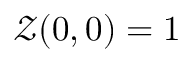<formula> <loc_0><loc_0><loc_500><loc_500>\mathcal { Z } ( 0 , 0 ) = 1</formula> 